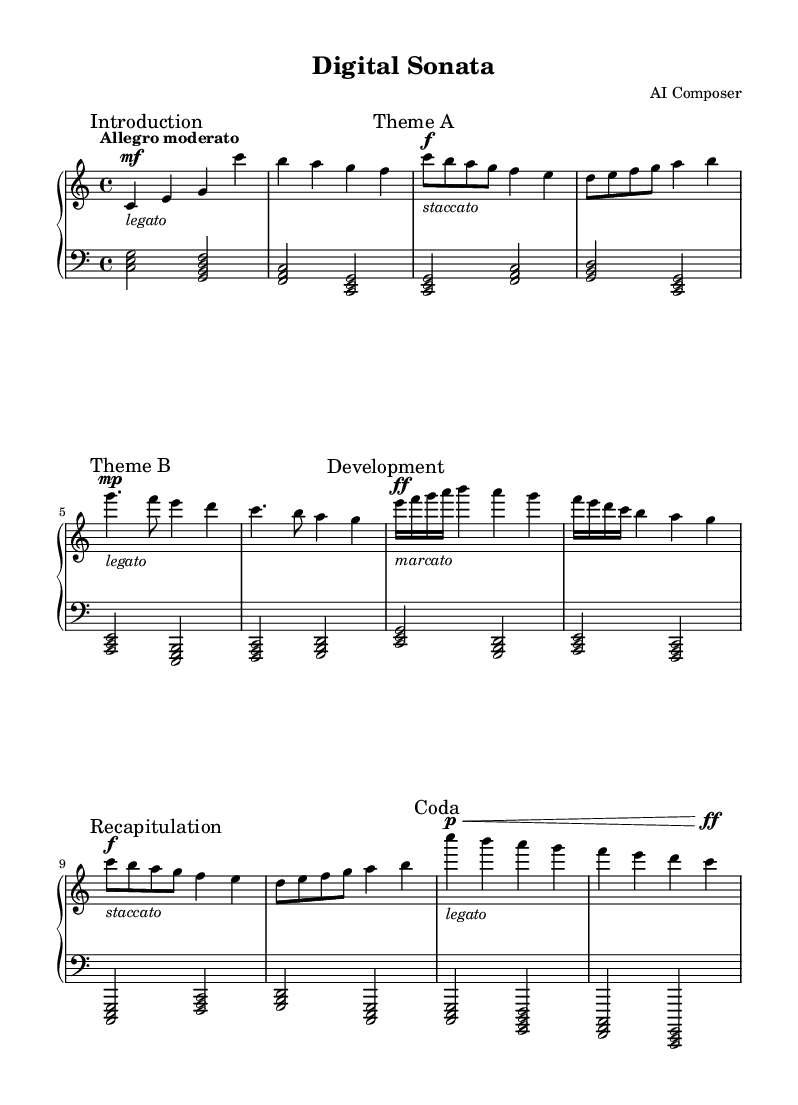What is the key signature of this music? The key signature is indicated at the beginning of the score, and it shows no sharps or flats, which corresponds to C major.
Answer: C major What is the time signature of this music? The time signature appears at the beginning of the piece as well; it is shown as 4/4, indicating four beats in a measure with a quarter note receiving one beat.
Answer: 4/4 What is the tempo marking for this piece? The tempo marking is specified in Italian at the beginning, stated as "Allegro moderato," which implies a moderately fast tempo.
Answer: Allegro moderato What is the dynamic marking for Theme A? Theme A has the dynamic marking "f," which means forte, or loud, indicated right before the section starts.
Answer: forte How many distinct themes are presented in this composition? By examining the score, there are two distinct thematic sections labeled as Theme A and Theme B, indicating there are two primary themes.
Answer: 2 How is the dynamic range utilized in the Development section? In the Development section, multiple dynamic contrasts are presented, starting with a "ff" (fortissimo) followed by "mp" (mezzo-piano), showcasing a wide dynamic range that adds emotional depth.
Answer: Wide dynamic range What does the term "legato" indicate in the Introduction? The term "legato" signifies that the notes should be played smoothly and connected, a directive which is visually marked at the beginning of the Introduction.
Answer: Smoothly connected 